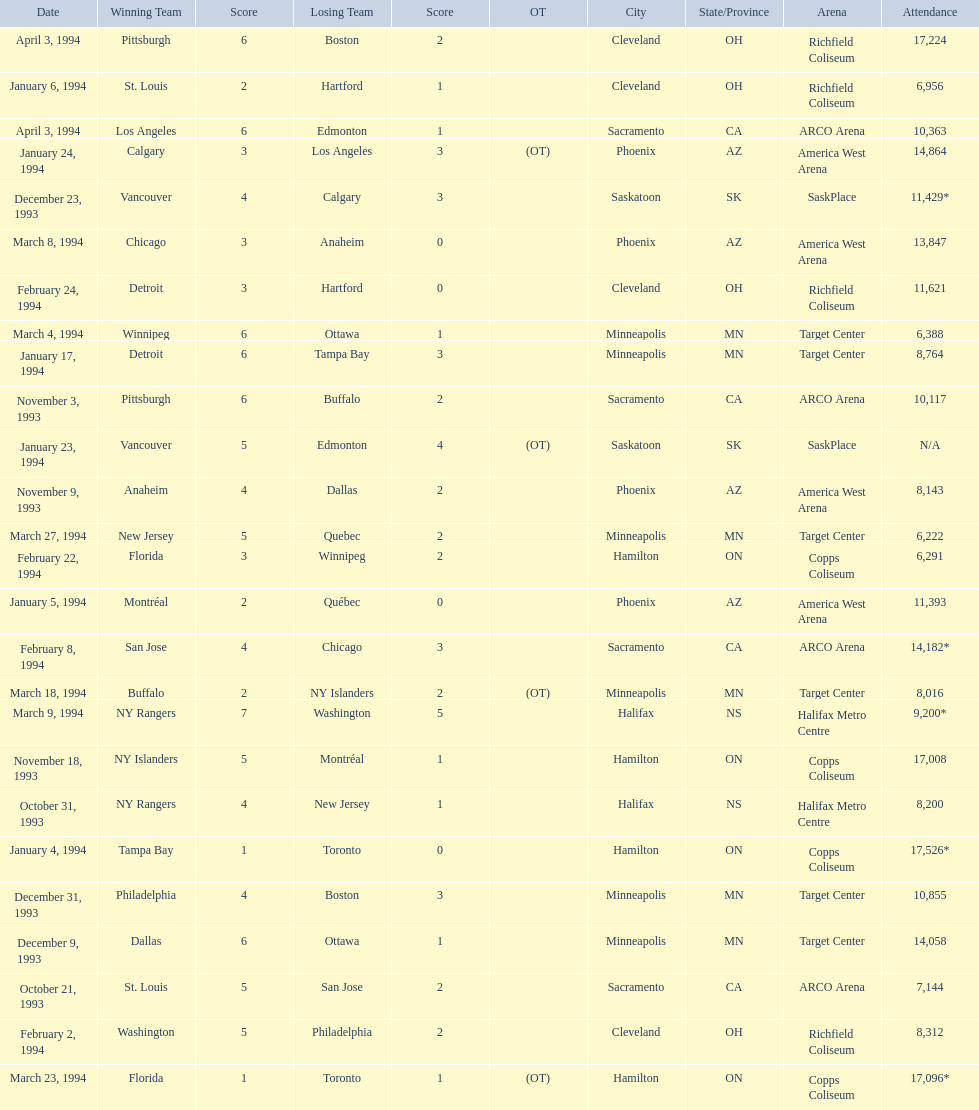Which dates saw the winning team score only one point? January 4, 1994, March 23, 1994. Of these two, which date had higher attendance? January 4, 1994. 